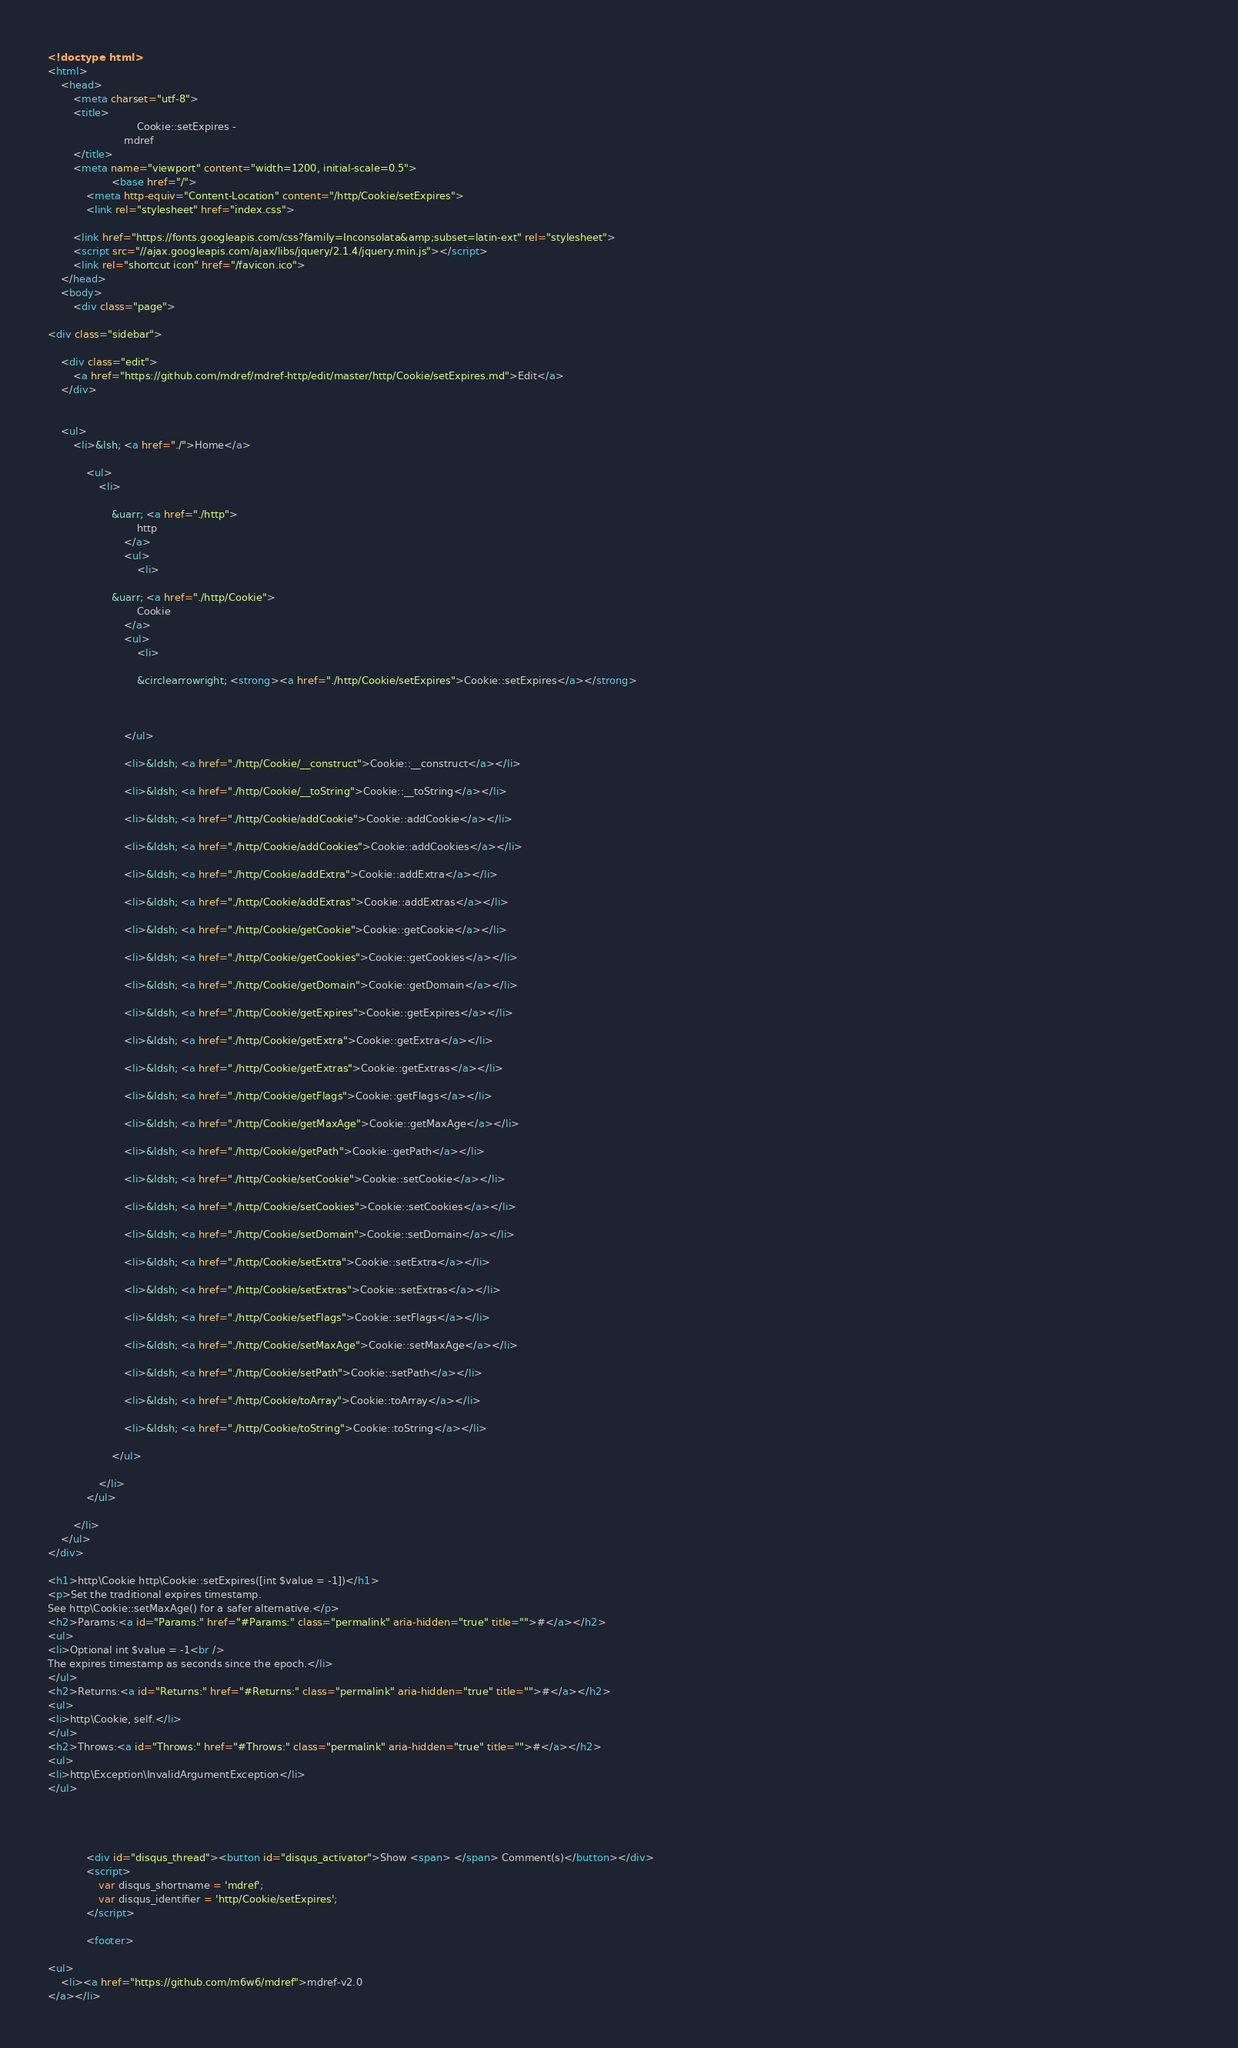<code> <loc_0><loc_0><loc_500><loc_500><_HTML_><!doctype html>
<html>
	<head>
		<meta charset="utf-8">
		<title>
							Cookie::setExpires -
						mdref
		</title>
		<meta name="viewport" content="width=1200, initial-scale=0.5">
					<base href="/">
			<meta http-equiv="Content-Location" content="/http/Cookie/setExpires">
			<link rel="stylesheet" href="index.css">
		
		<link href="https://fonts.googleapis.com/css?family=Inconsolata&amp;subset=latin-ext" rel="stylesheet">
		<script src="//ajax.googleapis.com/ajax/libs/jquery/2.1.4/jquery.min.js"></script>
		<link rel="shortcut icon" href="/favicon.ico">
	</head>
	<body>
		<div class="page">
		
<div class="sidebar">
	
	<div class="edit">
		<a href="https://github.com/mdref/mdref-http/edit/master/http/Cookie/setExpires.md">Edit</a>
	</div>
	
	
	<ul>
		<li>&lsh; <a href="./">Home</a>
			
			<ul>
				<li>
											
					&uarr; <a href="./http">
							http
						</a>
						<ul>
							<li>
																	
					&uarr; <a href="./http/Cookie">
							Cookie
						</a>
						<ul>
							<li>
											
							&circlearrowright; <strong><a href="./http/Cookie/setExpires">Cookie::setExpires</a></strong>

							
																																
						</ul>
																			
						<li>&ldsh; <a href="./http/Cookie/__construct">Cookie::__construct</a></li>
																			
						<li>&ldsh; <a href="./http/Cookie/__toString">Cookie::__toString</a></li>
																			
						<li>&ldsh; <a href="./http/Cookie/addCookie">Cookie::addCookie</a></li>
																			
						<li>&ldsh; <a href="./http/Cookie/addCookies">Cookie::addCookies</a></li>
																			
						<li>&ldsh; <a href="./http/Cookie/addExtra">Cookie::addExtra</a></li>
																			
						<li>&ldsh; <a href="./http/Cookie/addExtras">Cookie::addExtras</a></li>
																			
						<li>&ldsh; <a href="./http/Cookie/getCookie">Cookie::getCookie</a></li>
																			
						<li>&ldsh; <a href="./http/Cookie/getCookies">Cookie::getCookies</a></li>
																			
						<li>&ldsh; <a href="./http/Cookie/getDomain">Cookie::getDomain</a></li>
																			
						<li>&ldsh; <a href="./http/Cookie/getExpires">Cookie::getExpires</a></li>
																			
						<li>&ldsh; <a href="./http/Cookie/getExtra">Cookie::getExtra</a></li>
																			
						<li>&ldsh; <a href="./http/Cookie/getExtras">Cookie::getExtras</a></li>
																			
						<li>&ldsh; <a href="./http/Cookie/getFlags">Cookie::getFlags</a></li>
																			
						<li>&ldsh; <a href="./http/Cookie/getMaxAge">Cookie::getMaxAge</a></li>
																			
						<li>&ldsh; <a href="./http/Cookie/getPath">Cookie::getPath</a></li>
																			
						<li>&ldsh; <a href="./http/Cookie/setCookie">Cookie::setCookie</a></li>
																			
						<li>&ldsh; <a href="./http/Cookie/setCookies">Cookie::setCookies</a></li>
																			
						<li>&ldsh; <a href="./http/Cookie/setDomain">Cookie::setDomain</a></li>
																													
						<li>&ldsh; <a href="./http/Cookie/setExtra">Cookie::setExtra</a></li>
																			
						<li>&ldsh; <a href="./http/Cookie/setExtras">Cookie::setExtras</a></li>
																			
						<li>&ldsh; <a href="./http/Cookie/setFlags">Cookie::setFlags</a></li>
																			
						<li>&ldsh; <a href="./http/Cookie/setMaxAge">Cookie::setMaxAge</a></li>
																			
						<li>&ldsh; <a href="./http/Cookie/setPath">Cookie::setPath</a></li>
																			
						<li>&ldsh; <a href="./http/Cookie/toArray">Cookie::toArray</a></li>
																			
						<li>&ldsh; <a href="./http/Cookie/toString">Cookie::toString</a></li>
																																																																																										
					</ul>
													
				</li>
			</ul>
			
		</li>
	</ul>
</div>
					
<h1>http\Cookie http\Cookie::setExpires([int $value = -1])</h1>
<p>Set the traditional expires timestamp.
See http\Cookie::setMaxAge() for a safer alternative.</p>
<h2>Params:<a id="Params:" href="#Params:" class="permalink" aria-hidden="true" title="">#</a></h2>
<ul>
<li>Optional int $value = -1<br />
The expires timestamp as seconds since the epoch.</li>
</ul>
<h2>Returns:<a id="Returns:" href="#Returns:" class="permalink" aria-hidden="true" title="">#</a></h2>
<ul>
<li>http\Cookie, self.</li>
</ul>
<h2>Throws:<a id="Throws:" href="#Throws:" class="permalink" aria-hidden="true" title="">#</a></h2>
<ul>
<li>http\Exception\InvalidArgumentException</li>
</ul>



		
			<div id="disqus_thread"><button id="disqus_activator">Show <span> </span> Comment(s)</button></div>
			<script>
				var disqus_shortname = 'mdref';
				var disqus_identifier = 'http/Cookie/setExpires';
			</script>

			<footer>
				
<ul>
	<li><a href="https://github.com/m6w6/mdref">mdref-v2.0
</a></li></code> 